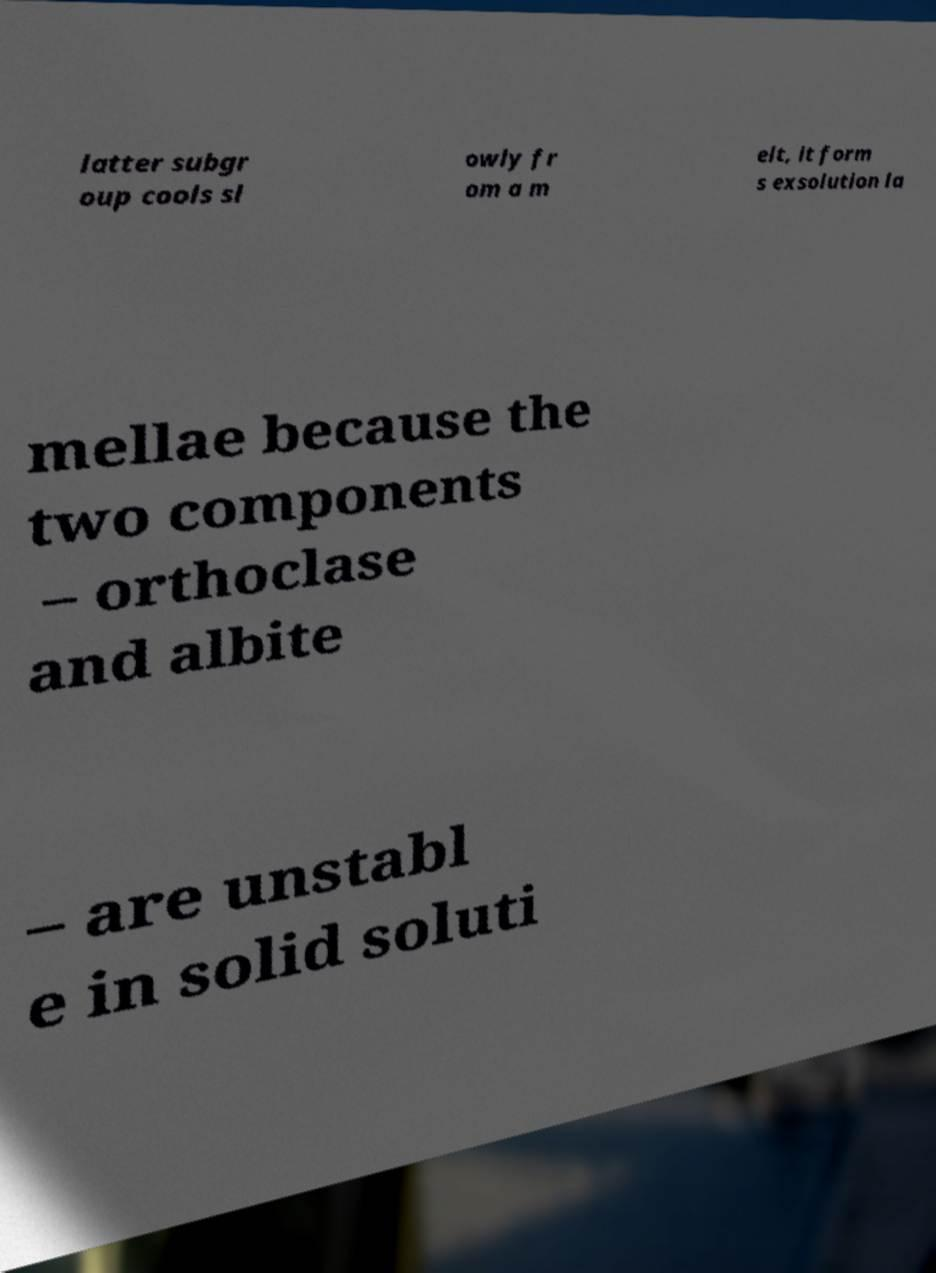Could you extract and type out the text from this image? latter subgr oup cools sl owly fr om a m elt, it form s exsolution la mellae because the two components – orthoclase and albite – are unstabl e in solid soluti 